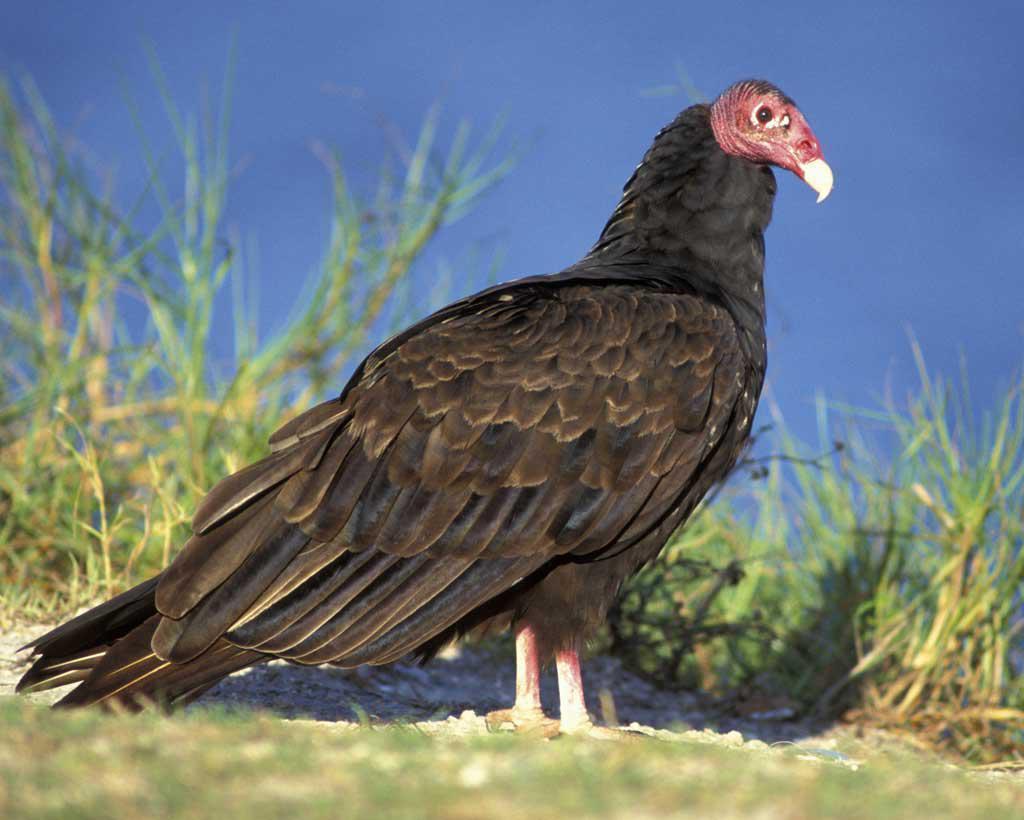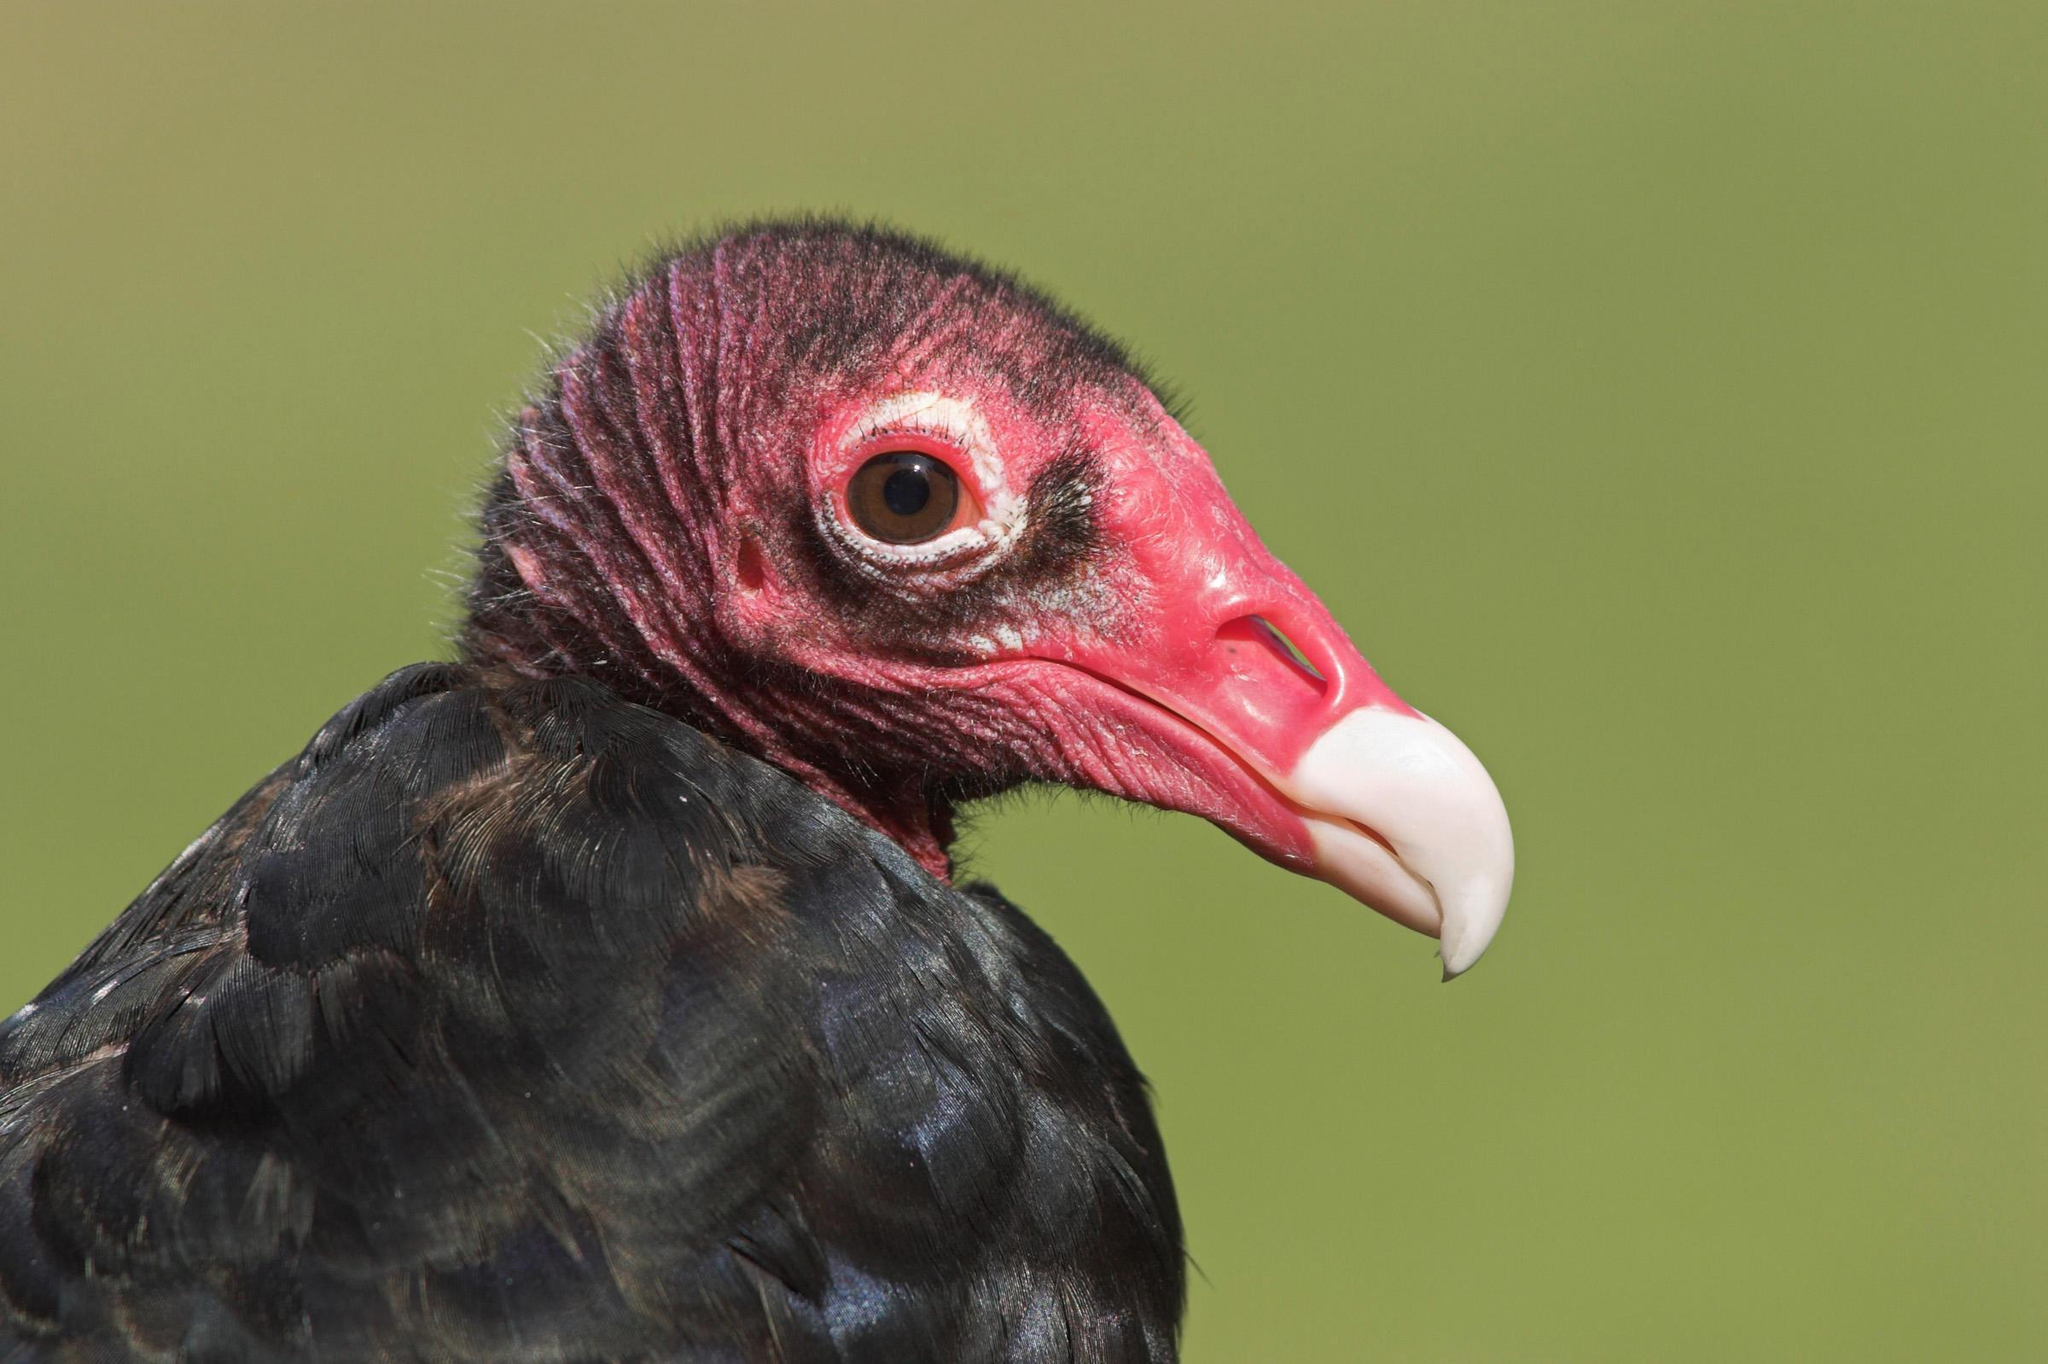The first image is the image on the left, the second image is the image on the right. Considering the images on both sides, is "There are two vultures flying" valid? Answer yes or no. No. 